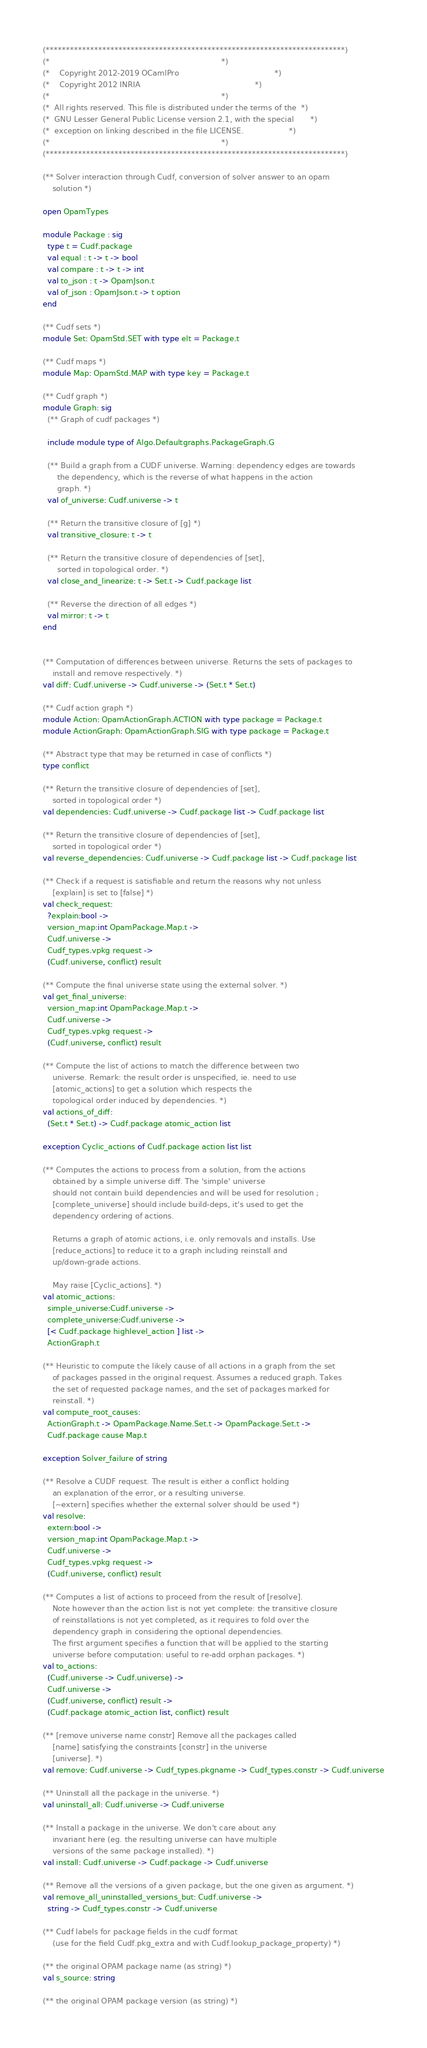<code> <loc_0><loc_0><loc_500><loc_500><_OCaml_>(**************************************************************************)
(*                                                                        *)
(*    Copyright 2012-2019 OCamlPro                                        *)
(*    Copyright 2012 INRIA                                                *)
(*                                                                        *)
(*  All rights reserved. This file is distributed under the terms of the  *)
(*  GNU Lesser General Public License version 2.1, with the special       *)
(*  exception on linking described in the file LICENSE.                   *)
(*                                                                        *)
(**************************************************************************)

(** Solver interaction through Cudf, conversion of solver answer to an opam
    solution *)

open OpamTypes

module Package : sig
  type t = Cudf.package
  val equal : t -> t -> bool
  val compare : t -> t -> int
  val to_json : t -> OpamJson.t
  val of_json : OpamJson.t -> t option
end

(** Cudf sets *)
module Set: OpamStd.SET with type elt = Package.t

(** Cudf maps *)
module Map: OpamStd.MAP with type key = Package.t

(** Cudf graph *)
module Graph: sig
  (** Graph of cudf packages *)

  include module type of Algo.Defaultgraphs.PackageGraph.G

  (** Build a graph from a CUDF universe. Warning: dependency edges are towards
      the dependency, which is the reverse of what happens in the action
      graph. *)
  val of_universe: Cudf.universe -> t

  (** Return the transitive closure of [g] *)
  val transitive_closure: t -> t

  (** Return the transitive closure of dependencies of [set],
      sorted in topological order. *)
  val close_and_linearize: t -> Set.t -> Cudf.package list

  (** Reverse the direction of all edges *)
  val mirror: t -> t
end


(** Computation of differences between universe. Returns the sets of packages to
    install and remove respectively. *)
val diff: Cudf.universe -> Cudf.universe -> (Set.t * Set.t)

(** Cudf action graph *)
module Action: OpamActionGraph.ACTION with type package = Package.t
module ActionGraph: OpamActionGraph.SIG with type package = Package.t

(** Abstract type that may be returned in case of conflicts *)
type conflict

(** Return the transitive closure of dependencies of [set],
    sorted in topological order *)
val dependencies: Cudf.universe -> Cudf.package list -> Cudf.package list

(** Return the transitive closure of dependencies of [set],
    sorted in topological order *)
val reverse_dependencies: Cudf.universe -> Cudf.package list -> Cudf.package list

(** Check if a request is satisfiable and return the reasons why not unless
    [explain] is set to [false] *)
val check_request:
  ?explain:bool ->
  version_map:int OpamPackage.Map.t ->
  Cudf.universe ->
  Cudf_types.vpkg request ->
  (Cudf.universe, conflict) result

(** Compute the final universe state using the external solver. *)
val get_final_universe:
  version_map:int OpamPackage.Map.t ->
  Cudf.universe ->
  Cudf_types.vpkg request ->
  (Cudf.universe, conflict) result

(** Compute the list of actions to match the difference between two
    universe. Remark: the result order is unspecified, ie. need to use
    [atomic_actions] to get a solution which respects the
    topological order induced by dependencies. *)
val actions_of_diff:
  (Set.t * Set.t) -> Cudf.package atomic_action list

exception Cyclic_actions of Cudf.package action list list

(** Computes the actions to process from a solution, from the actions
    obtained by a simple universe diff. The 'simple' universe
    should not contain build dependencies and will be used for resolution ;
    [complete_universe] should include build-deps, it's used to get the
    dependency ordering of actions.

    Returns a graph of atomic actions, i.e. only removals and installs. Use
    [reduce_actions] to reduce it to a graph including reinstall and
    up/down-grade actions.

    May raise [Cyclic_actions]. *)
val atomic_actions:
  simple_universe:Cudf.universe ->
  complete_universe:Cudf.universe ->
  [< Cudf.package highlevel_action ] list ->
  ActionGraph.t

(** Heuristic to compute the likely cause of all actions in a graph from the set
    of packages passed in the original request. Assumes a reduced graph. Takes
    the set of requested package names, and the set of packages marked for
    reinstall. *)
val compute_root_causes:
  ActionGraph.t -> OpamPackage.Name.Set.t -> OpamPackage.Set.t ->
  Cudf.package cause Map.t

exception Solver_failure of string

(** Resolve a CUDF request. The result is either a conflict holding
    an explanation of the error, or a resulting universe.
    [~extern] specifies whether the external solver should be used *)
val resolve:
  extern:bool ->
  version_map:int OpamPackage.Map.t ->
  Cudf.universe ->
  Cudf_types.vpkg request ->
  (Cudf.universe, conflict) result

(** Computes a list of actions to proceed from the result of [resolve].
    Note however than the action list is not yet complete: the transitive closure
    of reinstallations is not yet completed, as it requires to fold over the
    dependency graph in considering the optional dependencies.
    The first argument specifies a function that will be applied to the starting
    universe before computation: useful to re-add orphan packages. *)
val to_actions:
  (Cudf.universe -> Cudf.universe) ->
  Cudf.universe ->
  (Cudf.universe, conflict) result ->
  (Cudf.package atomic_action list, conflict) result

(** [remove universe name constr] Remove all the packages called
    [name] satisfying the constraints [constr] in the universe
    [universe]. *)
val remove: Cudf.universe -> Cudf_types.pkgname -> Cudf_types.constr -> Cudf.universe

(** Uninstall all the package in the universe. *)
val uninstall_all: Cudf.universe -> Cudf.universe

(** Install a package in the universe. We don't care about any
    invariant here (eg. the resulting universe can have multiple
    versions of the same package installed). *)
val install: Cudf.universe -> Cudf.package -> Cudf.universe

(** Remove all the versions of a given package, but the one given as argument. *)
val remove_all_uninstalled_versions_but: Cudf.universe ->
  string -> Cudf_types.constr -> Cudf.universe

(** Cudf labels for package fields in the cudf format
    (use for the field Cudf.pkg_extra and with Cudf.lookup_package_property) *)

(** the original OPAM package name (as string) *)
val s_source: string

(** the original OPAM package version (as string) *)</code> 